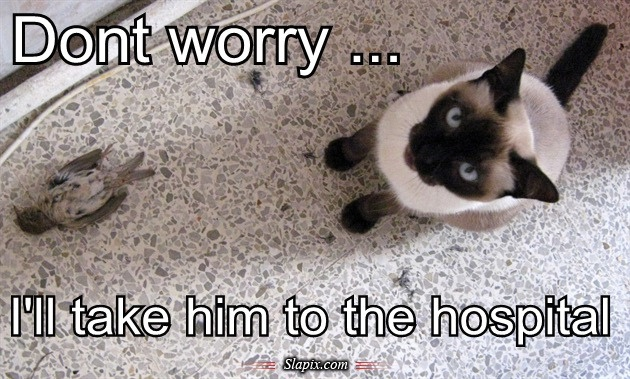Describe the objects in this image and their specific colors. I can see cat in darkgray, black, and gray tones and bird in darkgray, gray, and black tones in this image. 